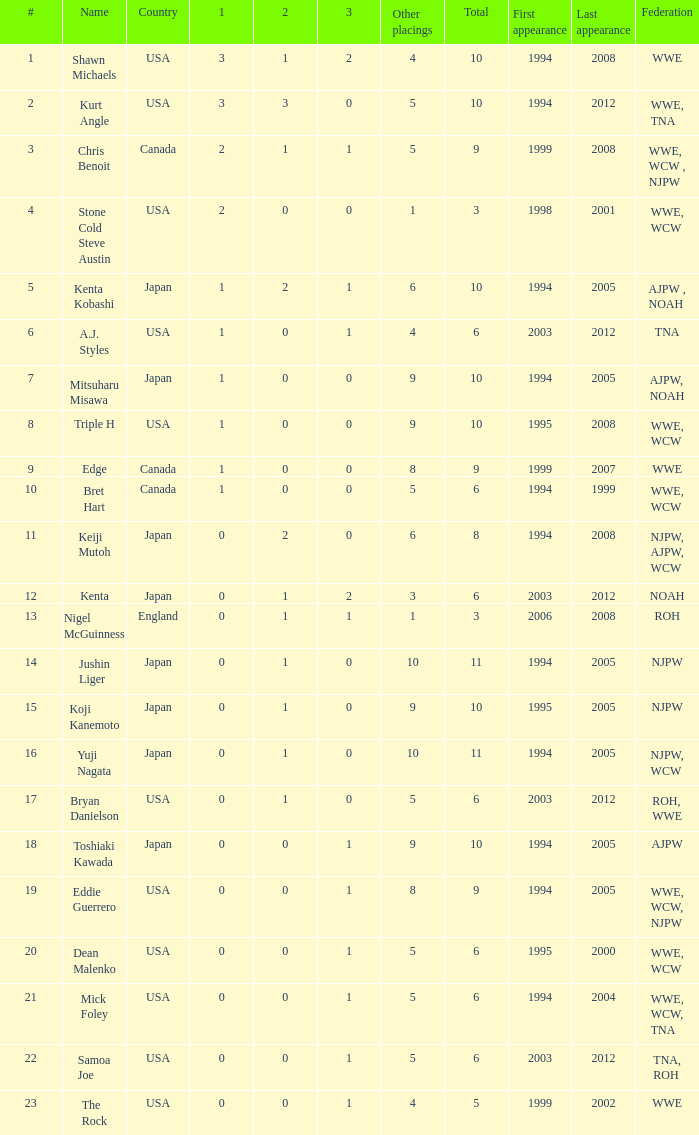What are the rank/s of Eddie Guerrero? 19.0. Give me the full table as a dictionary. {'header': ['#', 'Name', 'Country', '1', '2', '3', 'Other placings', 'Total', 'First appearance', 'Last appearance', 'Federation'], 'rows': [['1', 'Shawn Michaels', 'USA', '3', '1', '2', '4', '10', '1994', '2008', 'WWE'], ['2', 'Kurt Angle', 'USA', '3', '3', '0', '5', '10', '1994', '2012', 'WWE, TNA'], ['3', 'Chris Benoit', 'Canada', '2', '1', '1', '5', '9', '1999', '2008', 'WWE, WCW , NJPW'], ['4', 'Stone Cold Steve Austin', 'USA', '2', '0', '0', '1', '3', '1998', '2001', 'WWE, WCW'], ['5', 'Kenta Kobashi', 'Japan', '1', '2', '1', '6', '10', '1994', '2005', 'AJPW , NOAH'], ['6', 'A.J. Styles', 'USA', '1', '0', '1', '4', '6', '2003', '2012', 'TNA'], ['7', 'Mitsuharu Misawa', 'Japan', '1', '0', '0', '9', '10', '1994', '2005', 'AJPW, NOAH'], ['8', 'Triple H', 'USA', '1', '0', '0', '9', '10', '1995', '2008', 'WWE, WCW'], ['9', 'Edge', 'Canada', '1', '0', '0', '8', '9', '1999', '2007', 'WWE'], ['10', 'Bret Hart', 'Canada', '1', '0', '0', '5', '6', '1994', '1999', 'WWE, WCW'], ['11', 'Keiji Mutoh', 'Japan', '0', '2', '0', '6', '8', '1994', '2008', 'NJPW, AJPW, WCW'], ['12', 'Kenta', 'Japan', '0', '1', '2', '3', '6', '2003', '2012', 'NOAH'], ['13', 'Nigel McGuinness', 'England', '0', '1', '1', '1', '3', '2006', '2008', 'ROH'], ['14', 'Jushin Liger', 'Japan', '0', '1', '0', '10', '11', '1994', '2005', 'NJPW'], ['15', 'Koji Kanemoto', 'Japan', '0', '1', '0', '9', '10', '1995', '2005', 'NJPW'], ['16', 'Yuji Nagata', 'Japan', '0', '1', '0', '10', '11', '1994', '2005', 'NJPW, WCW'], ['17', 'Bryan Danielson', 'USA', '0', '1', '0', '5', '6', '2003', '2012', 'ROH, WWE'], ['18', 'Toshiaki Kawada', 'Japan', '0', '0', '1', '9', '10', '1994', '2005', 'AJPW'], ['19', 'Eddie Guerrero', 'USA', '0', '0', '1', '8', '9', '1994', '2005', 'WWE, WCW, NJPW'], ['20', 'Dean Malenko', 'USA', '0', '0', '1', '5', '6', '1995', '2000', 'WWE, WCW'], ['21', 'Mick Foley', 'USA', '0', '0', '1', '5', '6', '1994', '2004', 'WWE, WCW, TNA'], ['22', 'Samoa Joe', 'USA', '0', '0', '1', '5', '6', '2003', '2012', 'TNA, ROH'], ['23', 'The Rock', 'USA', '0', '0', '1', '4', '5', '1999', '2002', 'WWE']]} 